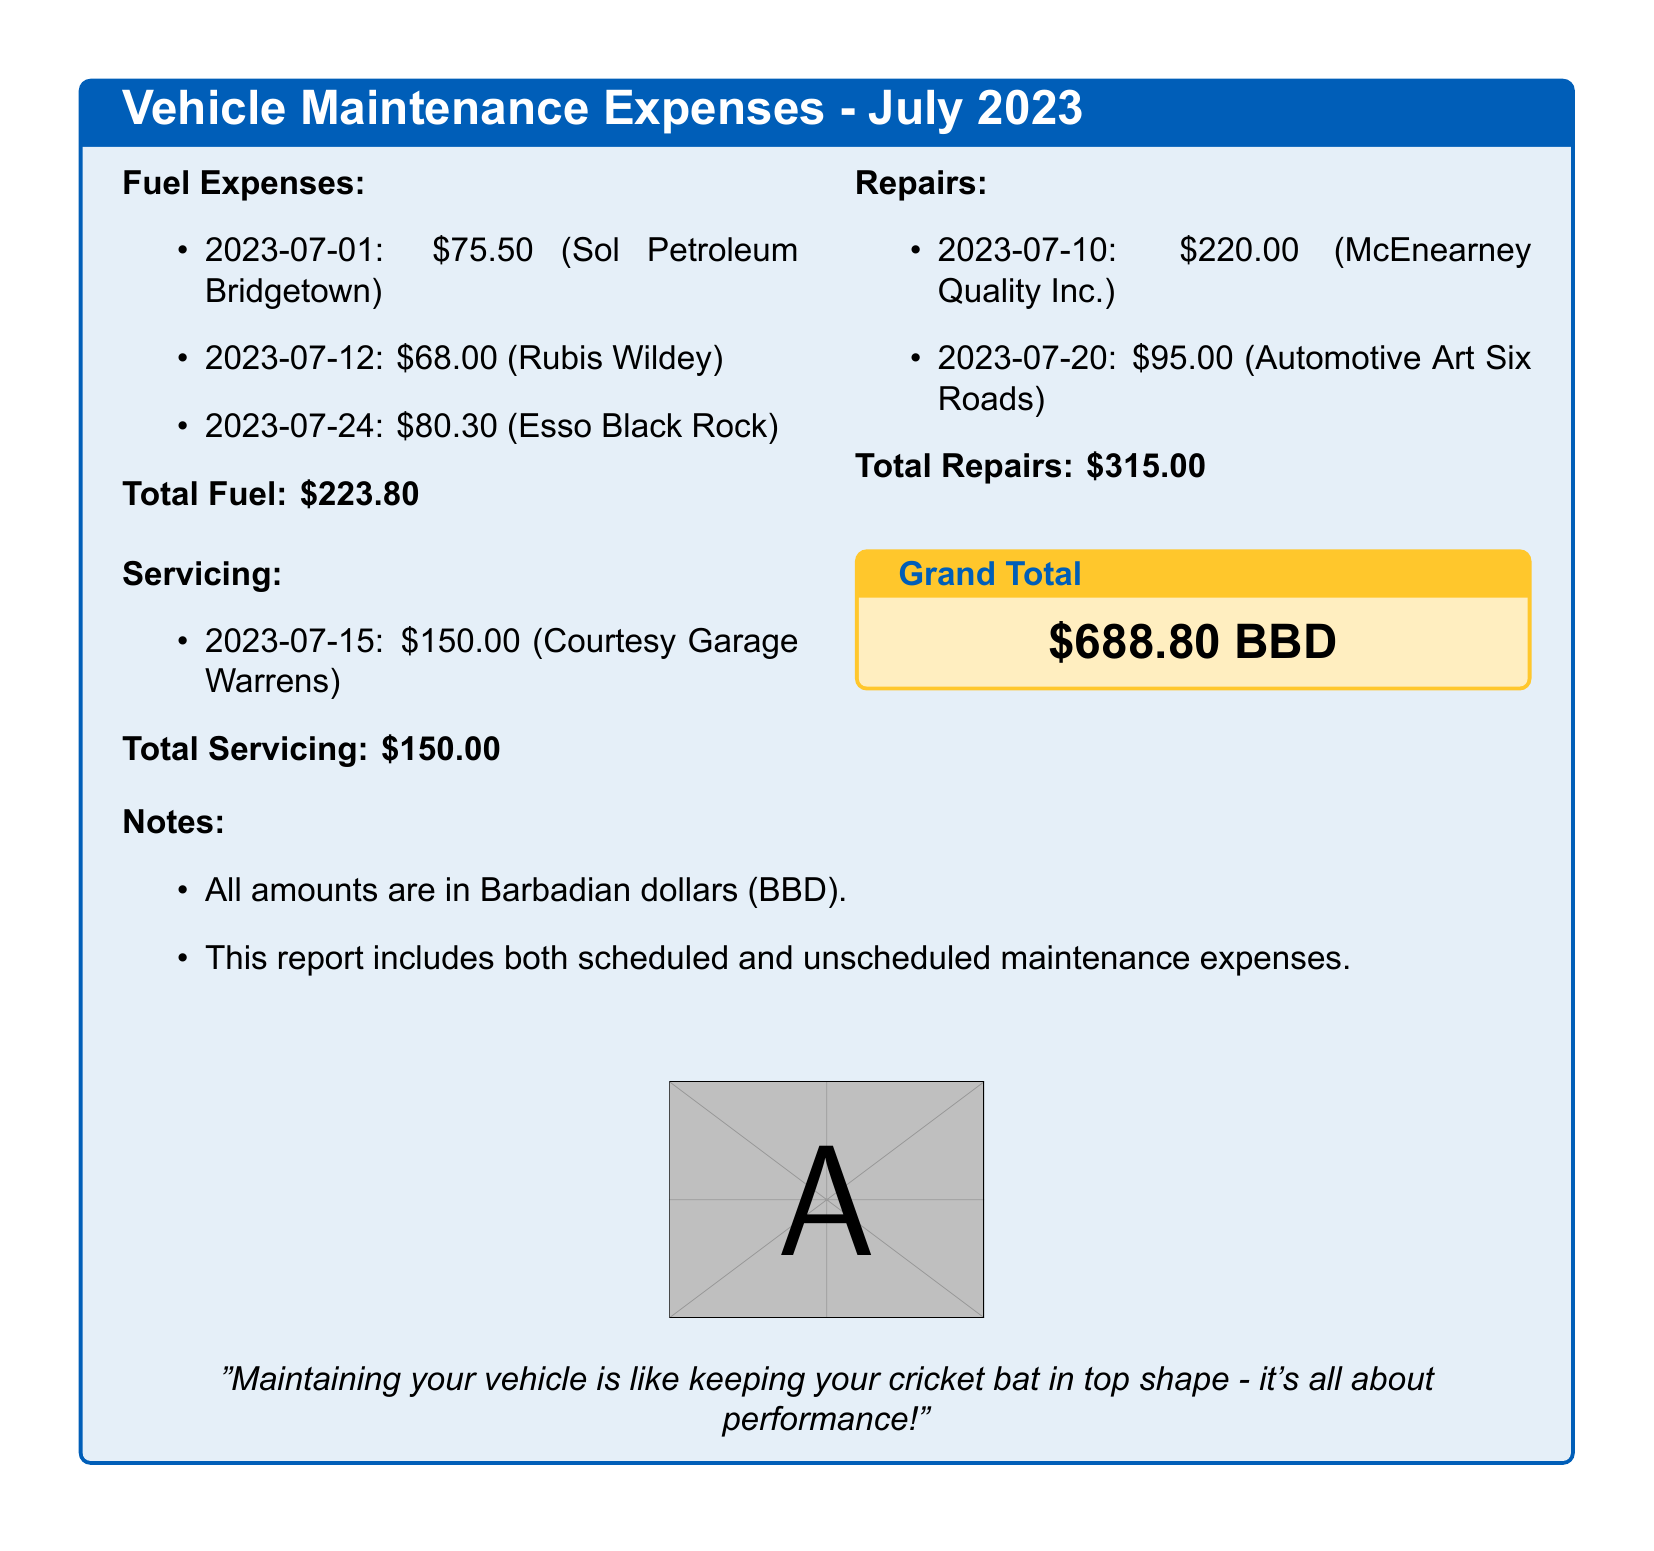what is the total fuel expense? The total fuel expense is found by adding all the individual fuel costs listed in the document, which are $75.50, $68.00, and $80.30.
Answer: $223.80 how many servicing expenses were recorded? There is one servicing expense detailed in the document, which was conducted on July 15.
Answer: 1 what is the total amount spent on repairs? The total amount spent on repairs is the sum of the two repair costs listed in the document: $220.00 and $95.00.
Answer: $315.00 when was the last fuel purchase made? The last fuel purchase was made on July 24, which is the most recent date listed for fuel expenses.
Answer: July 24 what is the grand total of vehicle maintenance expenses for July 2023? The grand total is calculated by summing the total fuel, servicing, and repairs expenses, as outlined in the document.
Answer: $688.80 BBD who provided the servicing? The servicing expense was provided by Courtesy Garage Warrens, which is mentioned next to the servicing cost.
Answer: Courtesy Garage Warrens are the expenses listed in the document in Barbados dollars? Yes, all amounts in the document are specified to be in Barbadian dollars (BBD).
Answer: Yes which company was involved in the first repair? The first repair mentioned in the document was done by McEnearney Quality Inc., indicating who performed the repair service.
Answer: McEnearney Quality Inc 